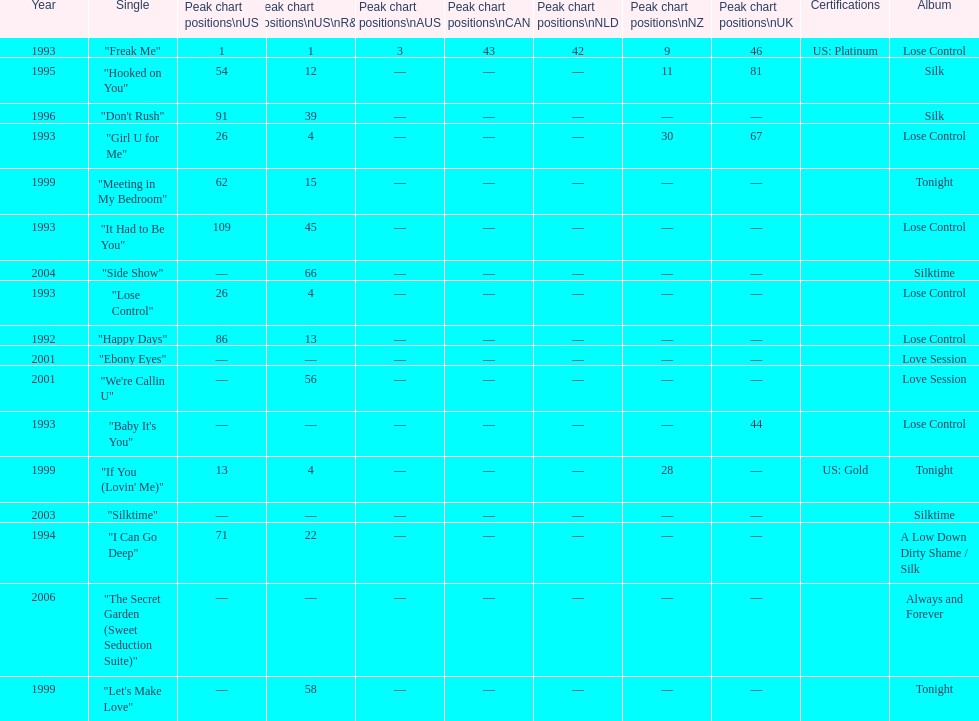Compare "i can go deep" with "don't rush". which was higher on the us and us r&b charts? "I Can Go Deep". 